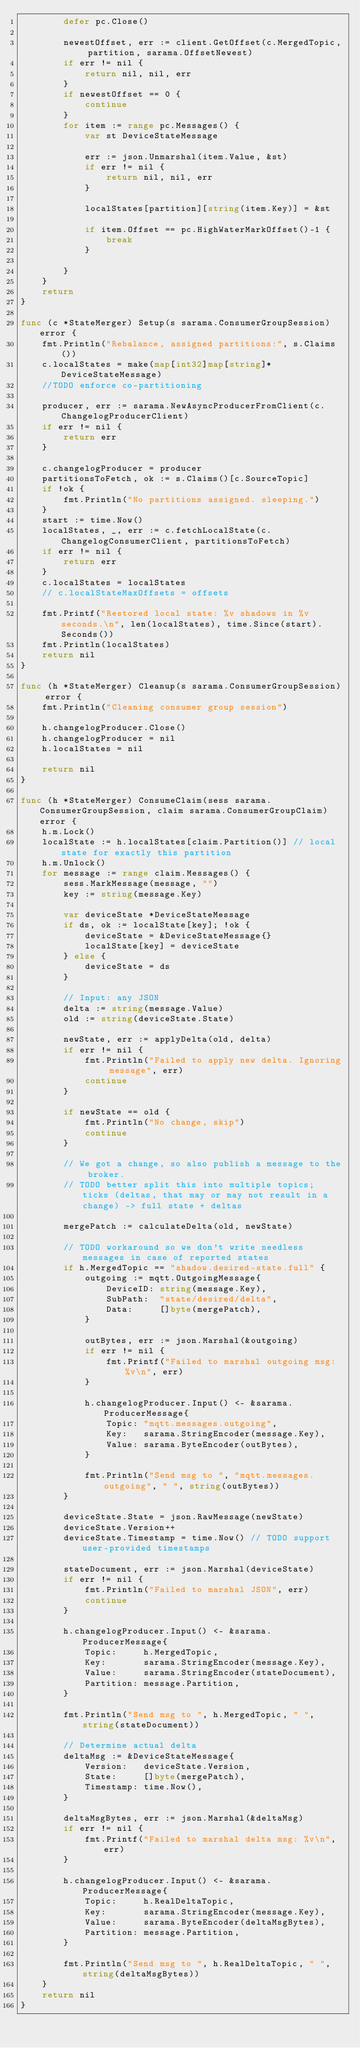<code> <loc_0><loc_0><loc_500><loc_500><_Go_>		defer pc.Close()

		newestOffset, err := client.GetOffset(c.MergedTopic, partition, sarama.OffsetNewest)
		if err != nil {
			return nil, nil, err
		}
		if newestOffset == 0 {
			continue
		}
		for item := range pc.Messages() {
			var st DeviceStateMessage

			err := json.Unmarshal(item.Value, &st)
			if err != nil {
				return nil, nil, err
			}

			localStates[partition][string(item.Key)] = &st

			if item.Offset == pc.HighWaterMarkOffset()-1 {
				break
			}

		}
	}
	return
}

func (c *StateMerger) Setup(s sarama.ConsumerGroupSession) error {
	fmt.Println("Rebalance, assigned partitions:", s.Claims())
	c.localStates = make(map[int32]map[string]*DeviceStateMessage)
	//TODO enforce co-partitioning

	producer, err := sarama.NewAsyncProducerFromClient(c.ChangelogProducerClient)
	if err != nil {
		return err
	}

	c.changelogProducer = producer
	partitionsToFetch, ok := s.Claims()[c.SourceTopic]
	if !ok {
		fmt.Println("No partitions assigned. sleeping.")
	}
	start := time.Now()
	localStates, _, err := c.fetchLocalState(c.ChangelogConsumerClient, partitionsToFetch)
	if err != nil {
		return err
	}
	c.localStates = localStates
	// c.localStateMaxOffsets = offsets

	fmt.Printf("Restored local state: %v shadows in %v seconds.\n", len(localStates), time.Since(start).Seconds())
	fmt.Println(localStates)
	return nil
}

func (h *StateMerger) Cleanup(s sarama.ConsumerGroupSession) error {
	fmt.Println("Cleaning consumer group session")

	h.changelogProducer.Close()
	h.changelogProducer = nil
	h.localStates = nil

	return nil
}

func (h *StateMerger) ConsumeClaim(sess sarama.ConsumerGroupSession, claim sarama.ConsumerGroupClaim) error {
	h.m.Lock()
	localState := h.localStates[claim.Partition()] // local state for exactly this partition
	h.m.Unlock()
	for message := range claim.Messages() {
		sess.MarkMessage(message, "")
		key := string(message.Key)

		var deviceState *DeviceStateMessage
		if ds, ok := localState[key]; !ok {
			deviceState = &DeviceStateMessage{}
			localState[key] = deviceState
		} else {
			deviceState = ds
		}

		// Input: any JSON
		delta := string(message.Value)
		old := string(deviceState.State)

		newState, err := applyDelta(old, delta)
		if err != nil {
			fmt.Println("Failed to apply new delta. Ignoring message", err)
			continue
		}

		if newState == old {
			fmt.Println("No change, skip")
			continue
		}

		// We got a change, so also publish a message to the broker.
		// TODO better split this into multiple topics; ticks (deltas, that may or may not result in a change) -> full state + deltas

		mergePatch := calculateDelta(old, newState)

		// TODO workaround so we don't write needless messages in case of reported states
		if h.MergedTopic == "shadow.desired-state.full" {
			outgoing := mqtt.OutgoingMessage{
				DeviceID: string(message.Key),
				SubPath:  "state/desired/delta",
				Data:     []byte(mergePatch),
			}

			outBytes, err := json.Marshal(&outgoing)
			if err != nil {
				fmt.Printf("Failed to marshal outgoing msg: %v\n", err)
			}

			h.changelogProducer.Input() <- &sarama.ProducerMessage{
				Topic: "mqtt.messages.outgoing",
				Key:   sarama.StringEncoder(message.Key),
				Value: sarama.ByteEncoder(outBytes),
			}

			fmt.Println("Send msg to ", "mqtt.messages.outgoing", " ", string(outBytes))
		}

		deviceState.State = json.RawMessage(newState)
		deviceState.Version++
		deviceState.Timestamp = time.Now() // TODO support user-provided timestamps

		stateDocument, err := json.Marshal(deviceState)
		if err != nil {
			fmt.Println("Failed to marshal JSON", err)
			continue
		}

		h.changelogProducer.Input() <- &sarama.ProducerMessage{
			Topic:     h.MergedTopic,
			Key:       sarama.StringEncoder(message.Key),
			Value:     sarama.StringEncoder(stateDocument),
			Partition: message.Partition,
		}

		fmt.Println("Send msg to ", h.MergedTopic, " ", string(stateDocument))

		// Determine actual delta
		deltaMsg := &DeviceStateMessage{
			Version:   deviceState.Version,
			State:     []byte(mergePatch),
			Timestamp: time.Now(),
		}

		deltaMsgBytes, err := json.Marshal(&deltaMsg)
		if err != nil {
			fmt.Printf("Failed to marshal delta msg: %v\n", err)
		}

		h.changelogProducer.Input() <- &sarama.ProducerMessage{
			Topic:     h.RealDeltaTopic,
			Key:       sarama.StringEncoder(message.Key),
			Value:     sarama.ByteEncoder(deltaMsgBytes),
			Partition: message.Partition,
		}

		fmt.Println("Send msg to ", h.RealDeltaTopic, " ", string(deltaMsgBytes))
	}
	return nil
}
</code> 